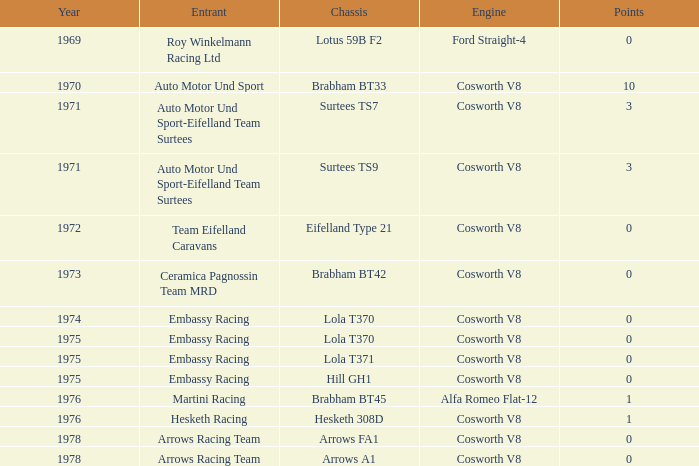Who had a cosworth v8 engine as their power source during the 1970 competition? Auto Motor Und Sport. 